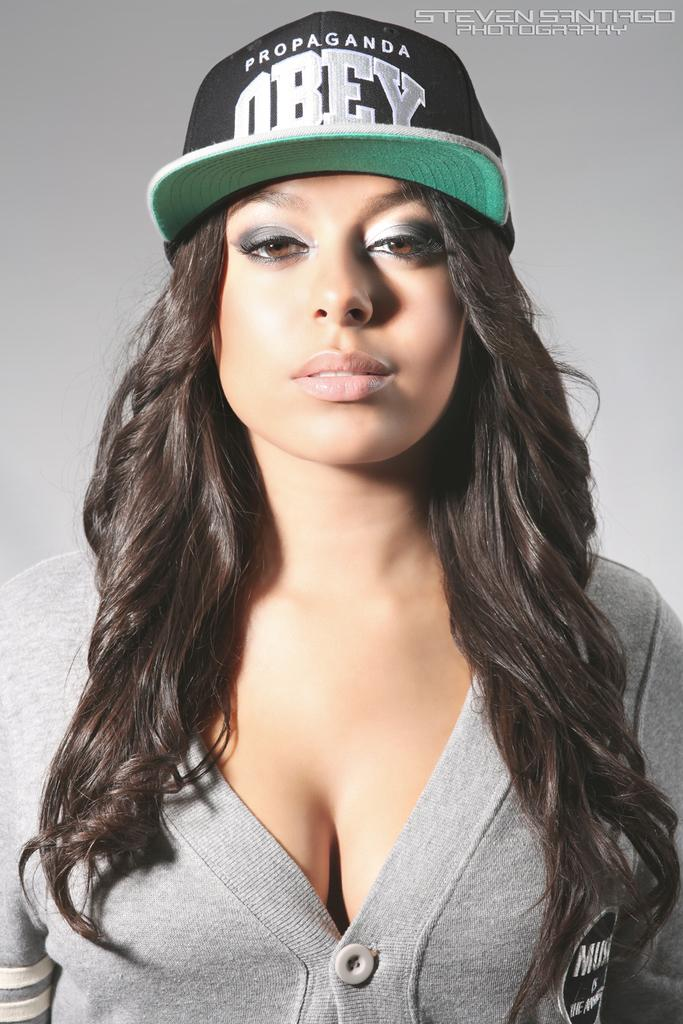Who or what is the main subject in the image? There is a person in the image. What is the person wearing on their upper body? The person is wearing a light gray color shirt. What type of headwear is the person wearing? The person is wearing a black and green color cap. Can you describe the background of the image? The background of the image is white and gray in color. What type of brake system can be seen in the image? There is no brake system present in the image; it features a person wearing a shirt and cap against a white and gray background. 